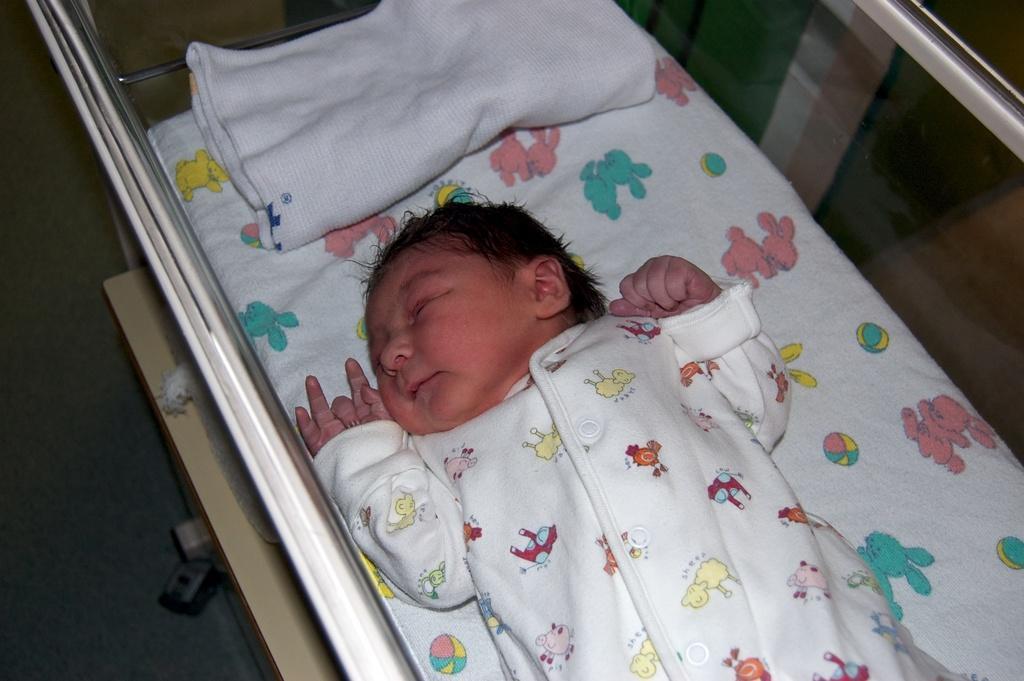In one or two sentences, can you explain what this image depicts? The picture consists of a baby in a bed. At the bottom we can see floor, wheel. 